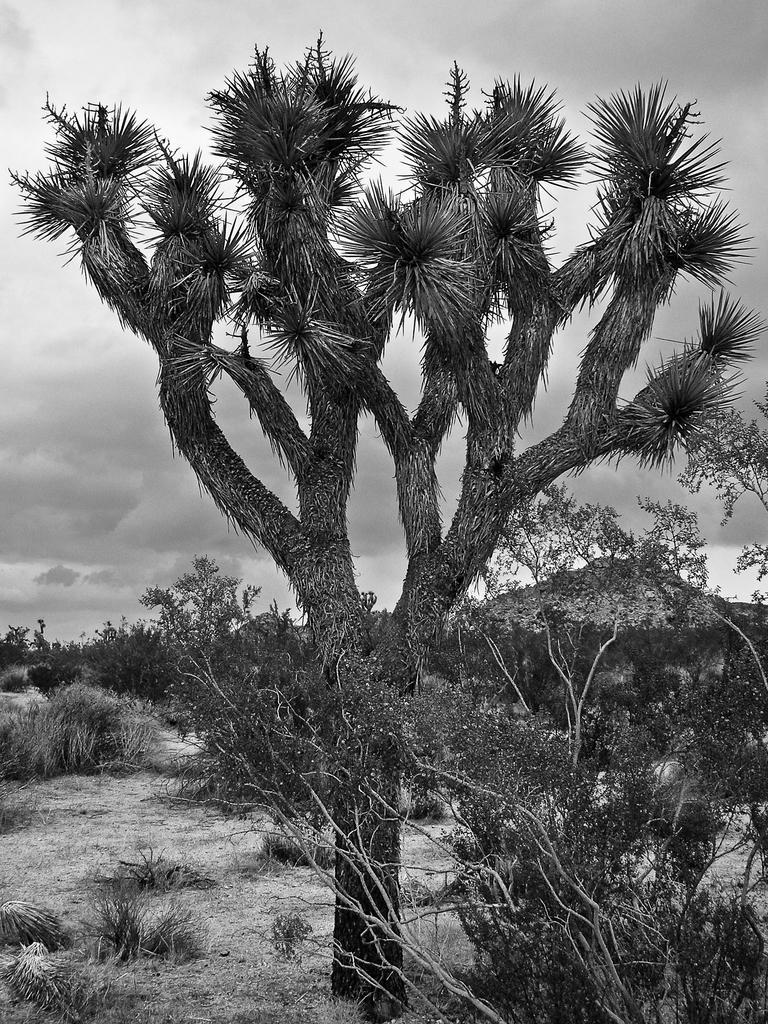Please provide a concise description of this image. In this image I can see few trees, background I can see the sky and the image is in black and white. 